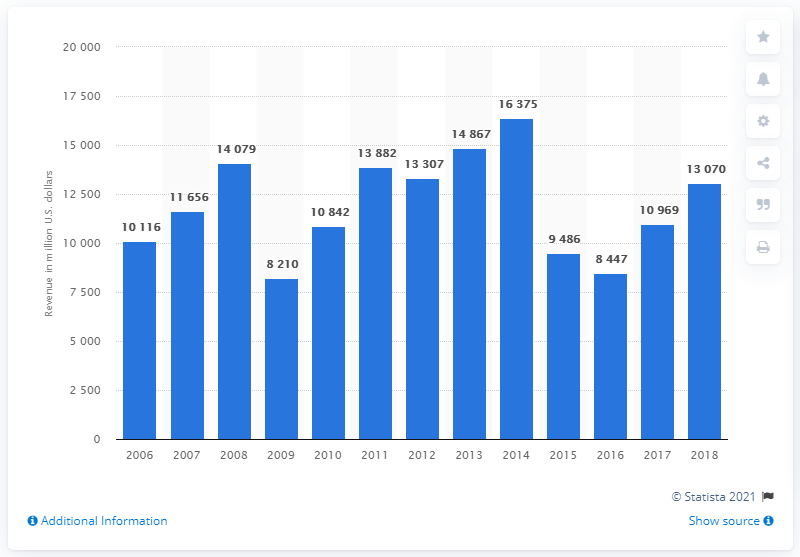Identify some key points in this picture. Anadarko Petroleum generated approximately 13,070 million US dollars in revenue in 2018. 